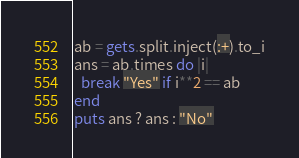Convert code to text. <code><loc_0><loc_0><loc_500><loc_500><_Ruby_>ab = gets.split.inject(:+).to_i
ans = ab.times do |i|
  break "Yes" if i**2 == ab
end
puts ans ? ans : "No"</code> 